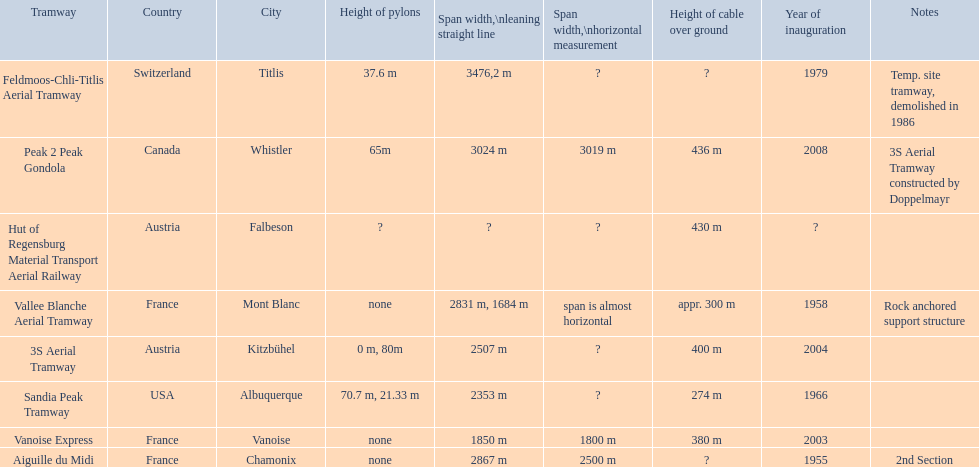When was the aiguille du midi tramway inaugurated? 1955. Can you give me this table in json format? {'header': ['Tramway', 'Country', 'City', 'Height of pylons', 'Span\xa0width,\\nleaning straight line', 'Span width,\\nhorizontal measurement', 'Height of cable over ground', 'Year of inauguration', 'Notes'], 'rows': [['Feldmoos-Chli-Titlis Aerial Tramway', 'Switzerland', 'Titlis', '37.6 m', '3476,2 m', '?', '?', '1979', 'Temp. site tramway, demolished in 1986'], ['Peak 2 Peak Gondola', 'Canada', 'Whistler', '65m', '3024 m', '3019 m', '436 m', '2008', '3S Aerial Tramway constructed by Doppelmayr'], ['Hut of Regensburg Material Transport Aerial Railway', 'Austria', 'Falbeson', '?', '?', '?', '430 m', '?', ''], ['Vallee Blanche Aerial Tramway', 'France', 'Mont Blanc', 'none', '2831 m, 1684 m', 'span is almost horizontal', 'appr. 300 m', '1958', 'Rock anchored support structure'], ['3S Aerial Tramway', 'Austria', 'Kitzbühel', '0 m, 80m', '2507 m', '?', '400 m', '2004', ''], ['Sandia Peak Tramway', 'USA', 'Albuquerque', '70.7 m, 21.33 m', '2353 m', '?', '274 m', '1966', ''], ['Vanoise Express', 'France', 'Vanoise', 'none', '1850 m', '1800 m', '380 m', '2003', ''], ['Aiguille du Midi', 'France', 'Chamonix', 'none', '2867 m', '2500 m', '?', '1955', '2nd Section']]} When was the 3s aerial tramway inaugurated? 2004. Which one was inaugurated first? Aiguille du Midi. 